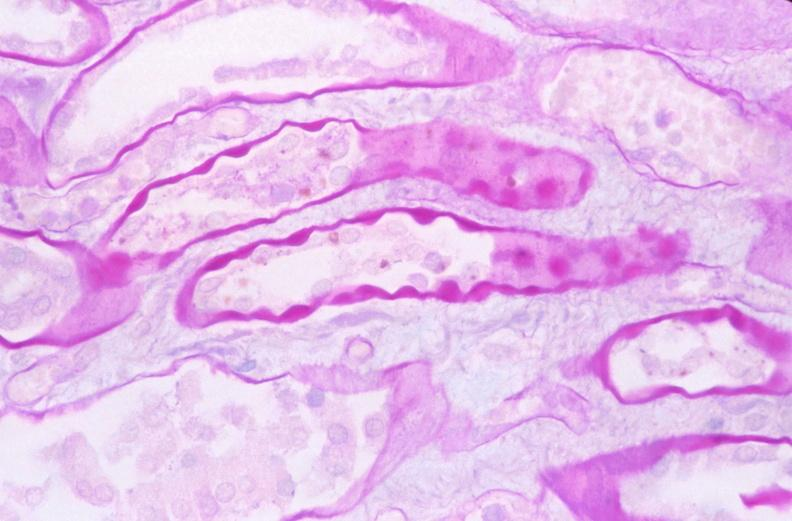why does this image show kidney, thickened and hyalinized basement membranes?
Answer the question using a single word or phrase. Due to diabetes mellitus pas 